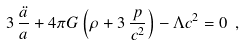<formula> <loc_0><loc_0><loc_500><loc_500>3 \, \frac { \ddot { a } } { a } + 4 \pi G \left ( \rho + 3 \, \frac { p } { c ^ { 2 } } \right ) - \Lambda c ^ { 2 } = 0 \ ,</formula> 